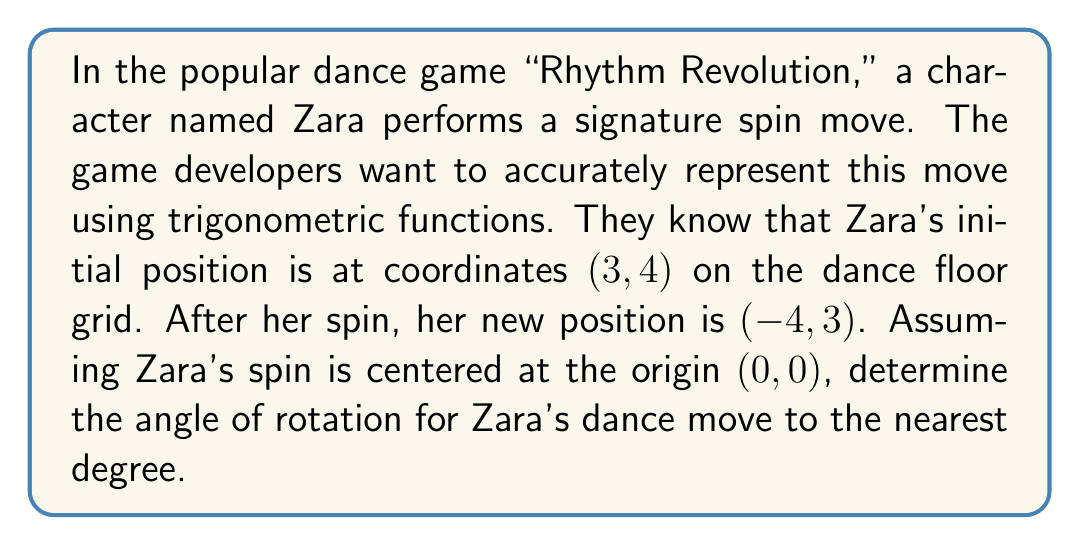Help me with this question. To solve this problem, we'll use the concept of rotation in the complex plane and the arctangent function. Let's break it down step-by-step:

1) First, we can represent Zara's initial position as a complex number:
   $z_1 = 3 + 4i$

2) Her final position after the spin can also be represented as a complex number:
   $z_2 = -4 + 3i$

3) In the complex plane, rotation by an angle $\theta$ is represented by multiplication by $e^{i\theta}$. So we have:
   $z_2 = z_1 \cdot e^{i\theta}$

4) To find $\theta$, we can divide $z_2$ by $z_1$:
   $\frac{z_2}{z_1} = e^{i\theta} = \cos\theta + i\sin\theta$

5) Let's perform this division:
   $$\frac{z_2}{z_1} = \frac{-4+3i}{3+4i} \cdot \frac{3-4i}{3-4i} = \frac{(-4+3i)(3-4i)}{(3+4i)(3-4i)} = \frac{-12+16i+9i-12i^2}{9+16} = \frac{0+25i}{25} = i$$

6) So, $e^{i\theta} = i = 0 + i$

7) Comparing this with the general form $\cos\theta + i\sin\theta$, we see that:
   $\cos\theta = 0$ and $\sin\theta = 1$

8) This occurs when $\theta = 90°$ or $\frac{\pi}{2}$ radians.

Therefore, Zara's spin is a 90° rotation counterclockwise.
Answer: 90° 